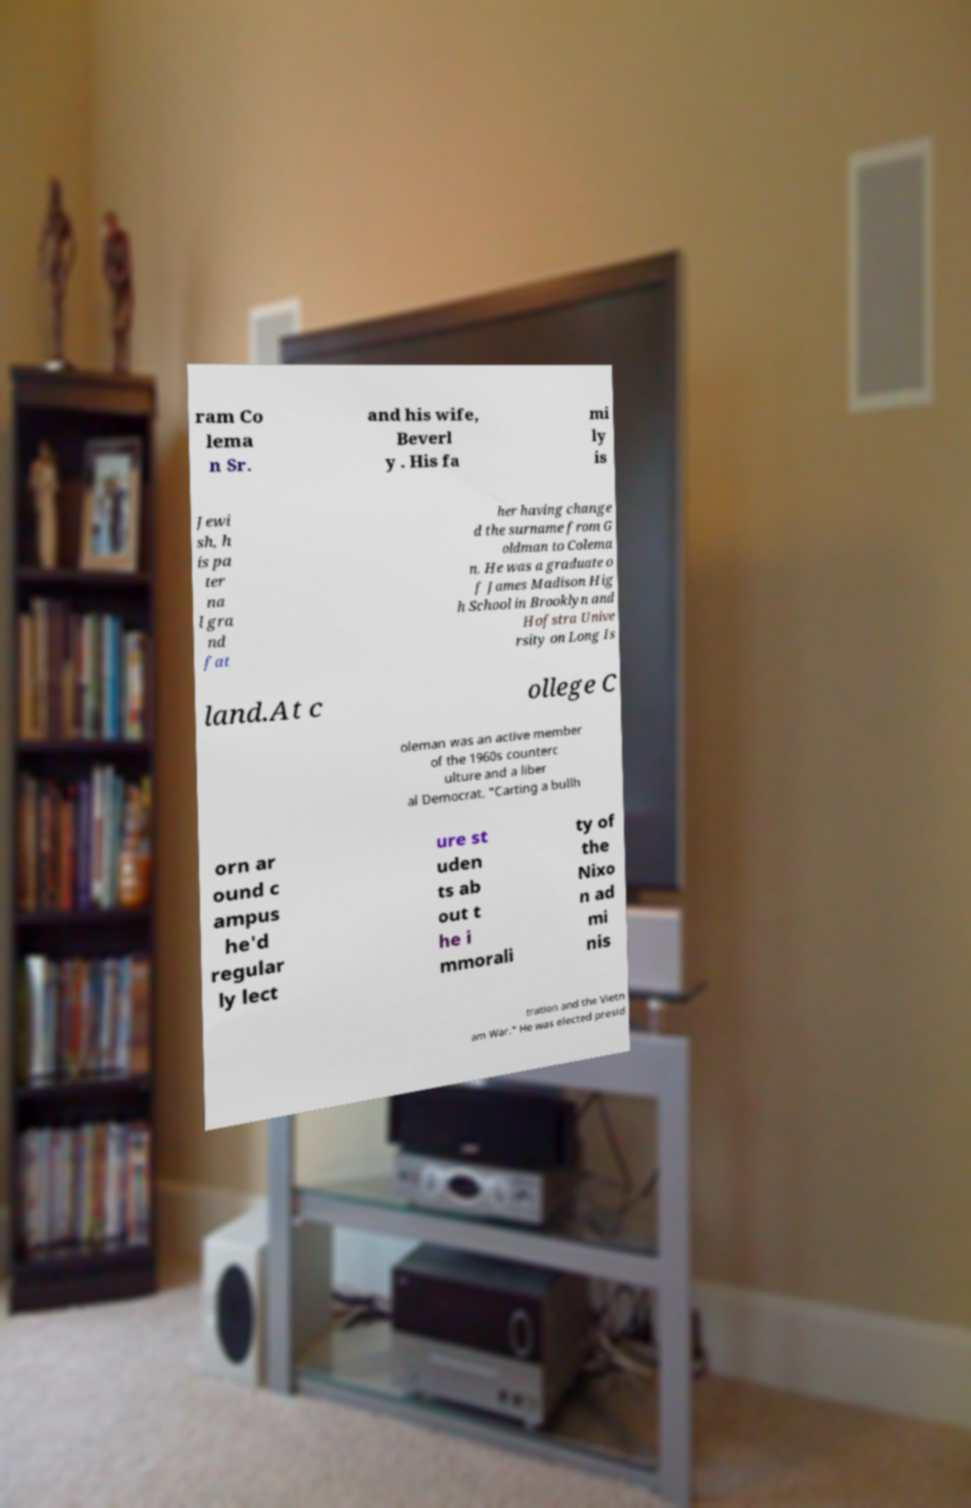I need the written content from this picture converted into text. Can you do that? ram Co lema n Sr. and his wife, Beverl y . His fa mi ly is Jewi sh, h is pa ter na l gra nd fat her having change d the surname from G oldman to Colema n. He was a graduate o f James Madison Hig h School in Brooklyn and Hofstra Unive rsity on Long Is land.At c ollege C oleman was an active member of the 1960s counterc ulture and a liber al Democrat. "Carting a bullh orn ar ound c ampus he'd regular ly lect ure st uden ts ab out t he i mmorali ty of the Nixo n ad mi nis tration and the Vietn am War." He was elected presid 